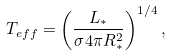<formula> <loc_0><loc_0><loc_500><loc_500>T _ { e f f } = \left ( \frac { L _ { \ast } } { \sigma 4 \pi R _ { \ast } ^ { 2 } } \right ) ^ { 1 / 4 } ,</formula> 